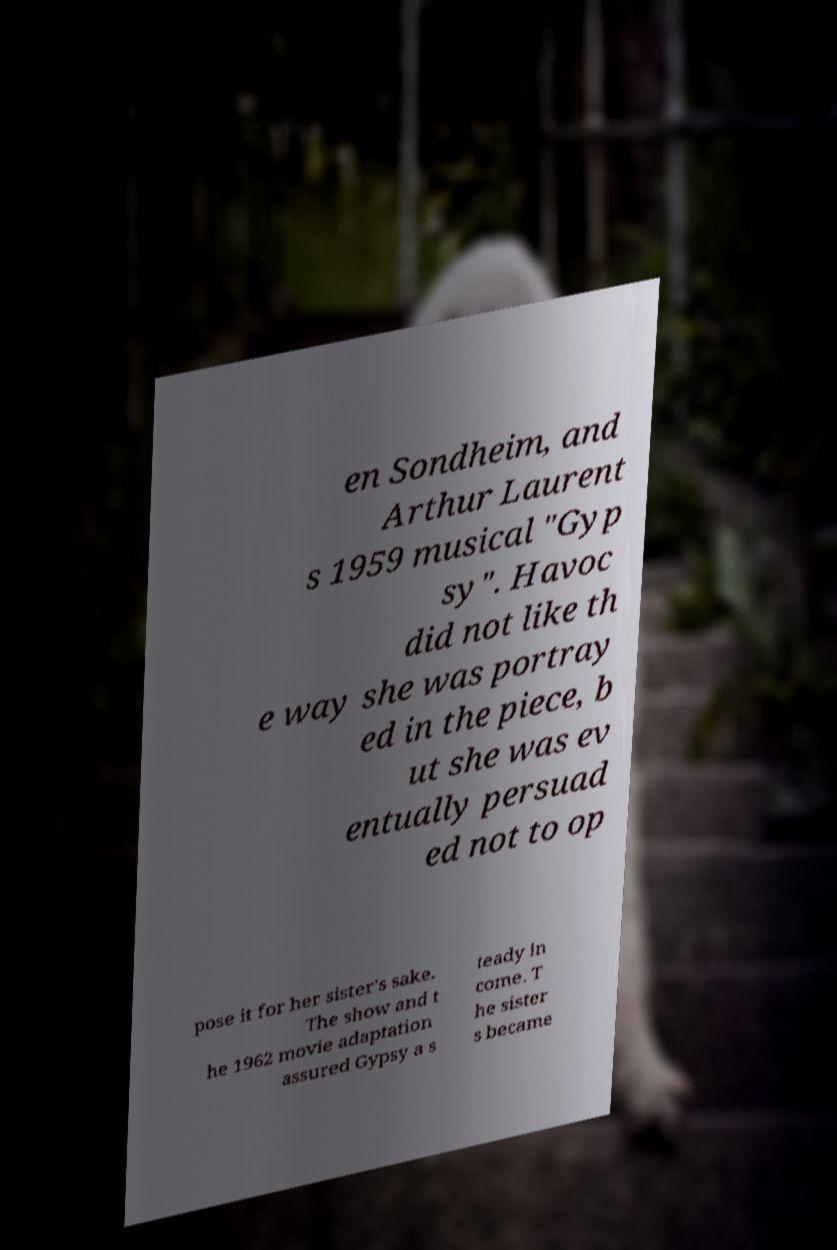Can you read and provide the text displayed in the image?This photo seems to have some interesting text. Can you extract and type it out for me? en Sondheim, and Arthur Laurent s 1959 musical "Gyp sy". Havoc did not like th e way she was portray ed in the piece, b ut she was ev entually persuad ed not to op pose it for her sister's sake. The show and t he 1962 movie adaptation assured Gypsy a s teady in come. T he sister s became 